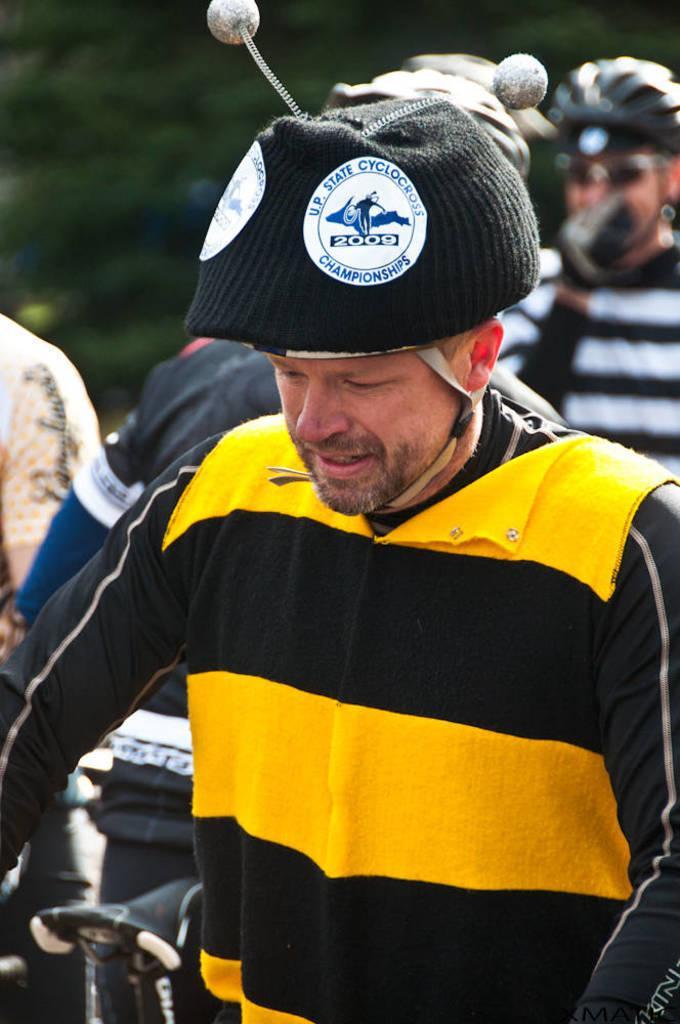Describe this image in one or two sentences. In this image we can see a group of people and trees. 